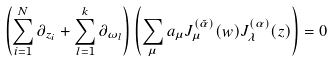<formula> <loc_0><loc_0><loc_500><loc_500>\left ( \sum _ { i = 1 } ^ { N } \partial _ { z _ { i } } + \sum _ { l = 1 } ^ { k } \partial _ { \omega _ { l } } \right ) \left ( \sum _ { \mu } a _ { \mu } J _ { \mu } ^ { ( \tilde { \alpha } ) } ( w ) J _ { \lambda } ^ { ( \alpha ) } ( z ) \right ) = 0</formula> 